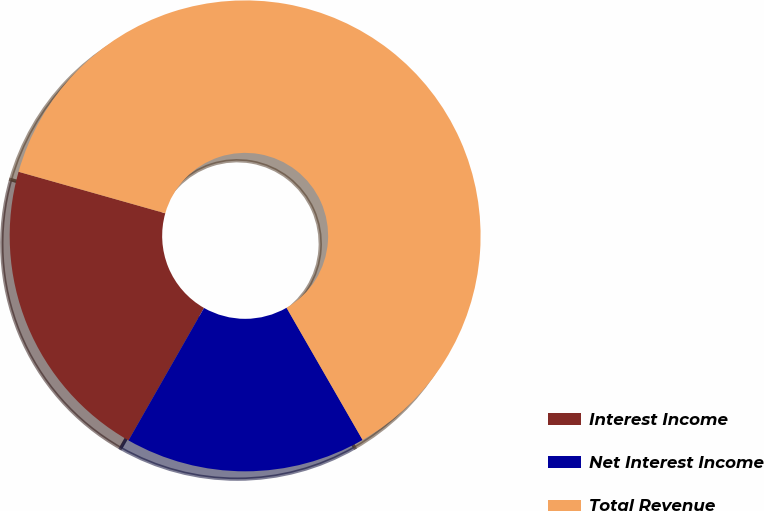<chart> <loc_0><loc_0><loc_500><loc_500><pie_chart><fcel>Interest Income<fcel>Net Interest Income<fcel>Total Revenue<nl><fcel>21.14%<fcel>16.56%<fcel>62.3%<nl></chart> 